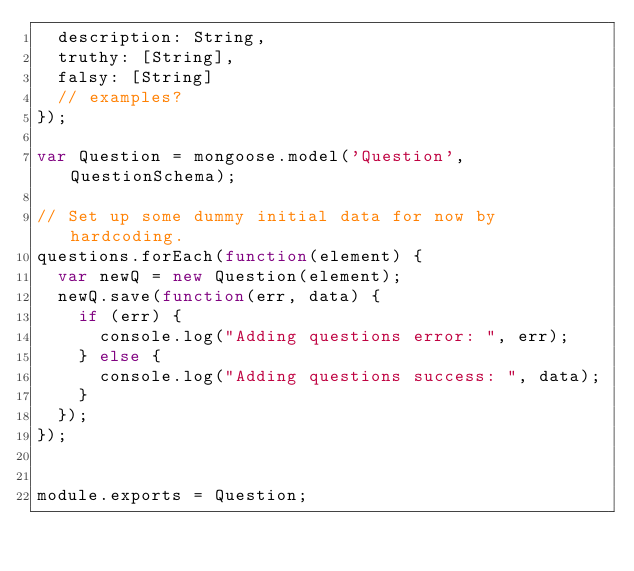<code> <loc_0><loc_0><loc_500><loc_500><_JavaScript_>  description: String,
  truthy: [String],
  falsy: [String]
  // examples?
});

var Question = mongoose.model('Question', QuestionSchema);

// Set up some dummy initial data for now by hardcoding.
questions.forEach(function(element) {
  var newQ = new Question(element);
  newQ.save(function(err, data) {
    if (err) {
      console.log("Adding questions error: ", err);
    } else {
      console.log("Adding questions success: ", data);
    }
  });
});


module.exports = Question;

</code> 